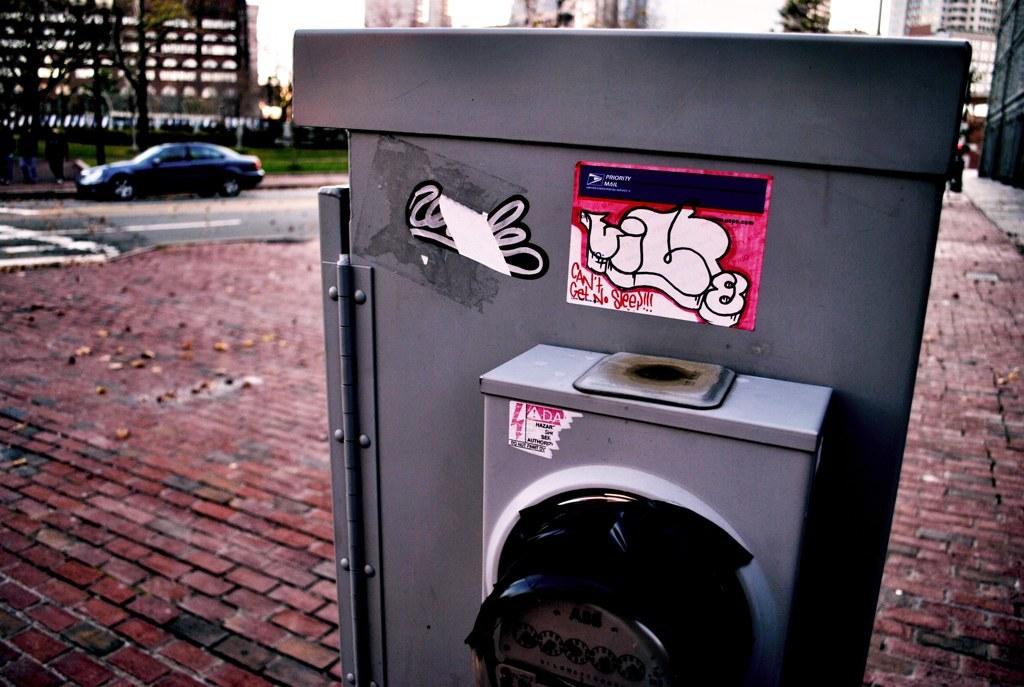What number is on the pink sticker?
Make the answer very short. 8. What is on the sticker?
Your response must be concise. Unanswerable. 